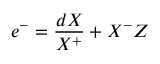<formula> <loc_0><loc_0><loc_500><loc_500>e ^ { - } = \frac { d X } { X ^ { + } } + X ^ { - } Z</formula> 